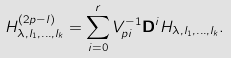<formula> <loc_0><loc_0><loc_500><loc_500>H ^ { ( 2 p - l ) } _ { \lambda , l _ { 1 } , \dots , l _ { k } } = \sum _ { i = 0 } ^ { r } V ^ { - 1 } _ { p i } \mathbf D ^ { i } H _ { \lambda , l _ { 1 } , \dots , l _ { k } } .</formula> 